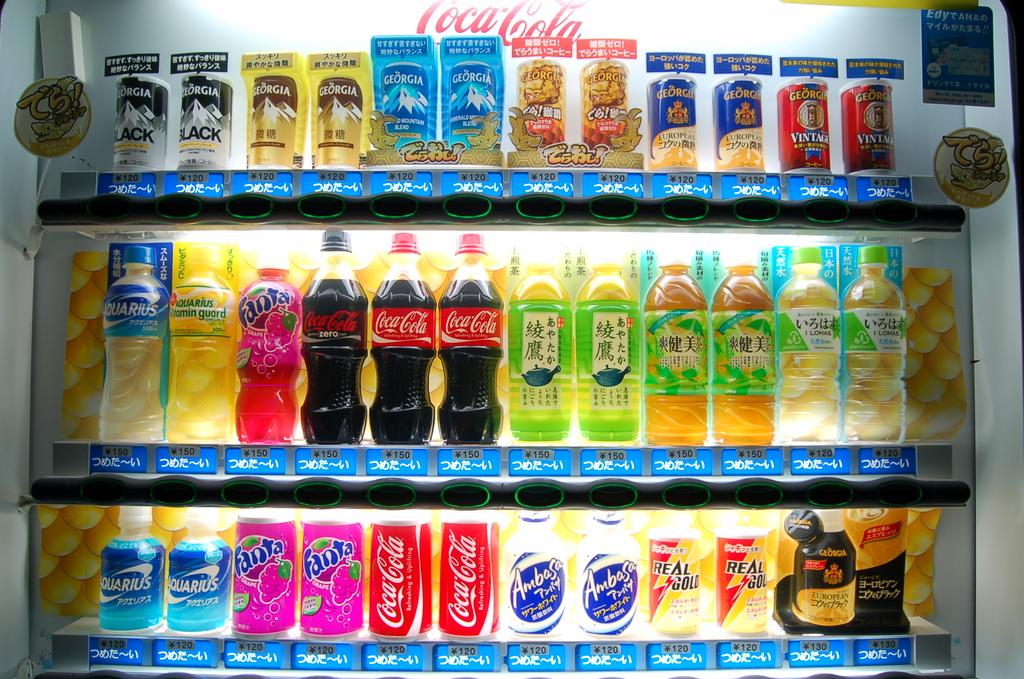How many cans of coca cola is in this machine?
Your response must be concise. Answering does not require reading text in the image. 